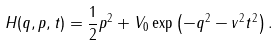<formula> <loc_0><loc_0><loc_500><loc_500>H ( q , p , t ) = \frac { 1 } { 2 } p ^ { 2 } + V _ { 0 } \exp \left ( - q ^ { 2 } - v ^ { 2 } t ^ { 2 } \right ) .</formula> 